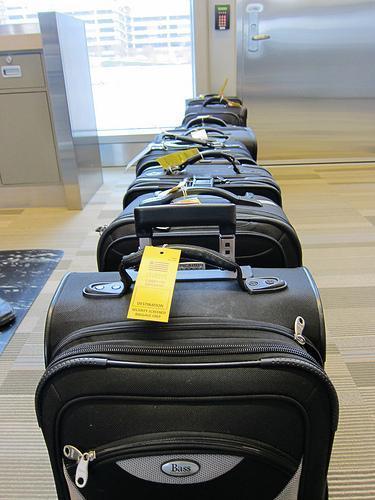How many bags are there?
Give a very brief answer. 7. 